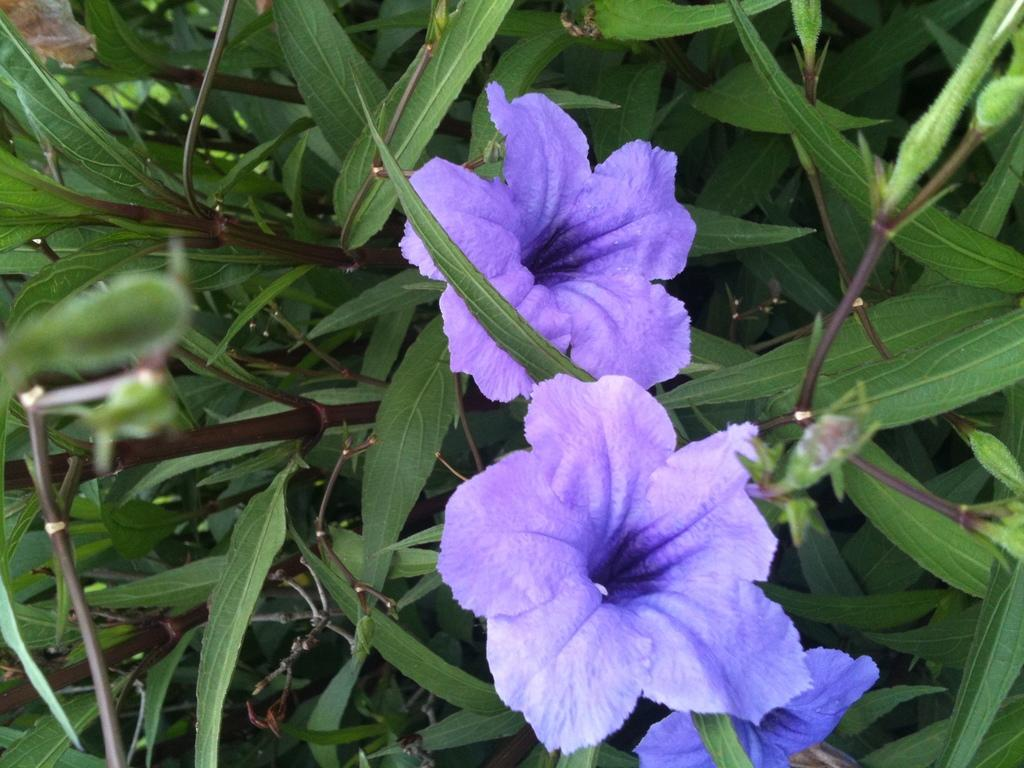What type of living organisms can be seen in the image? Plants can be seen in the image. What color are the leaves of the plants in the image? The leaves of the plants in the image are green. What color are the flowers of the plants in the image? The flowers of the plants in the image are blue. Can you see the foot of the mother in the image? There is no foot or mother present in the image; it only features plants with green leaves and blue flowers. 